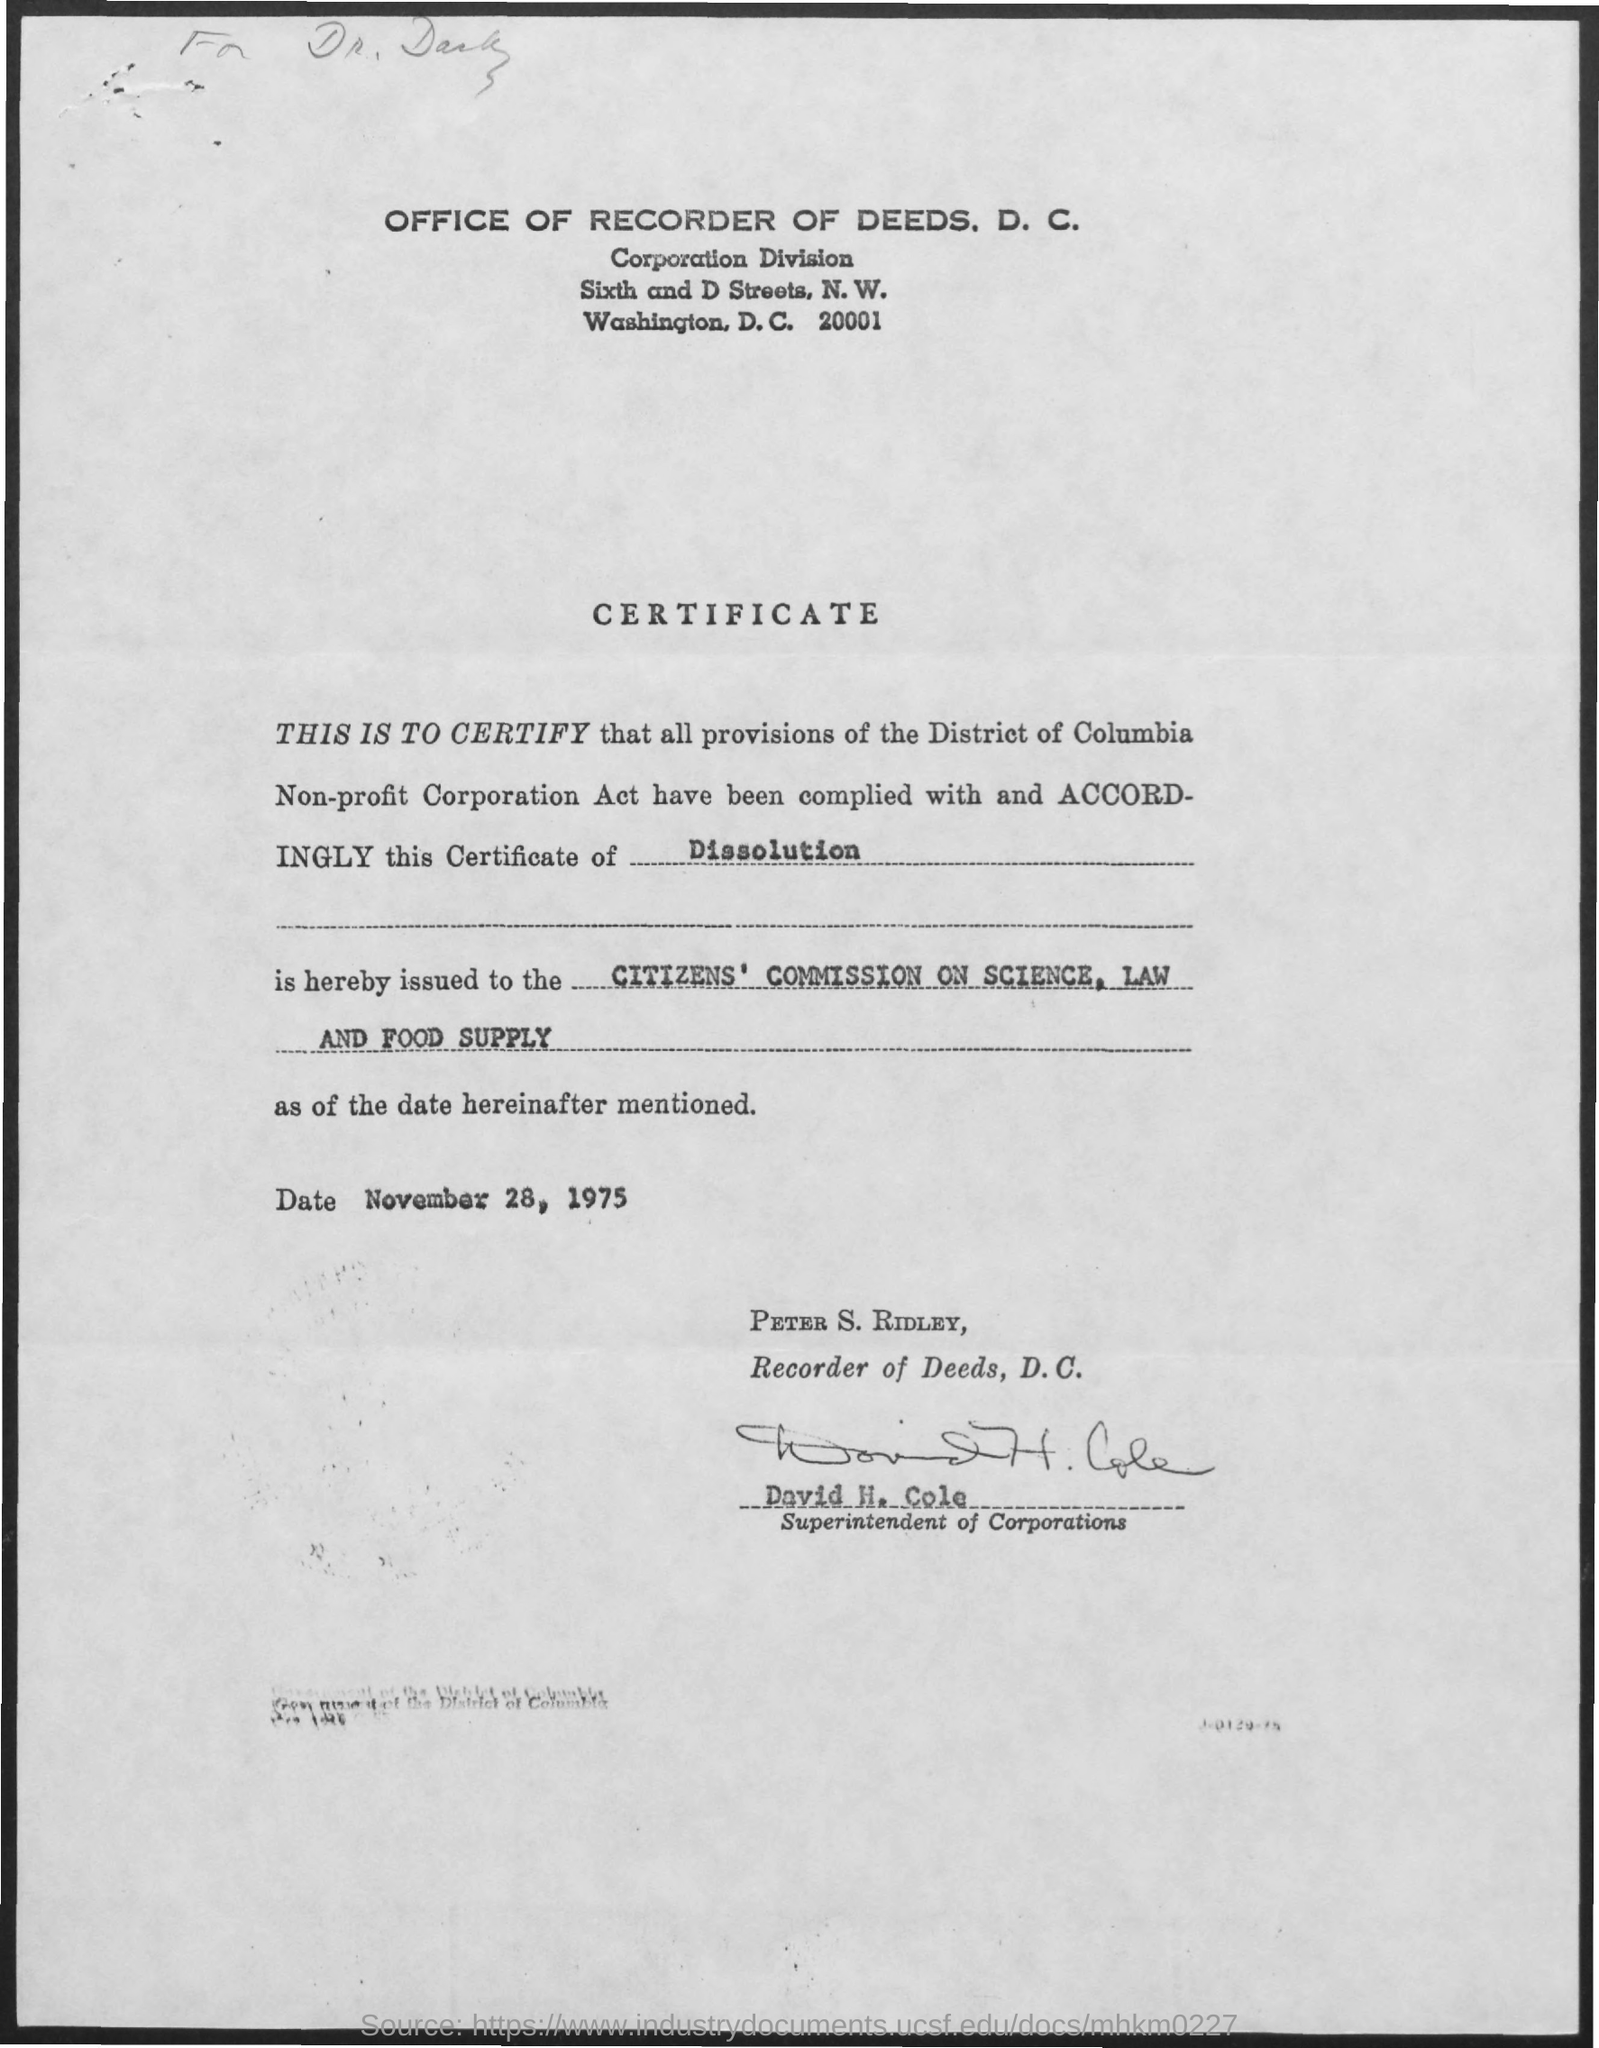Draw attention to some important aspects in this diagram. The individual who holds the position of Recorder of Deeds in the District of Columbia is Peter S. Ridley. The date mentioned is November 28, 1975. David H. Cole is the superintendent of corporations. 